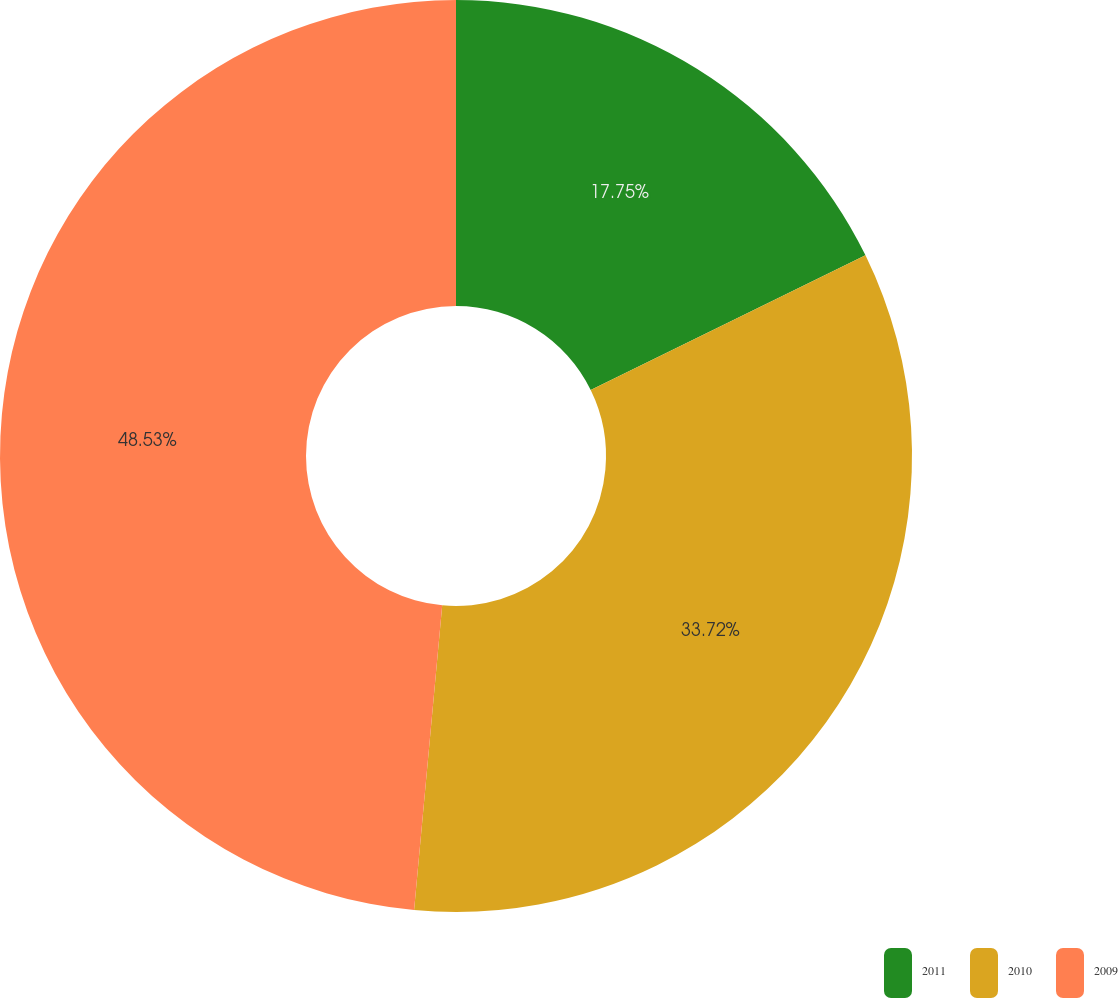Convert chart to OTSL. <chart><loc_0><loc_0><loc_500><loc_500><pie_chart><fcel>2011<fcel>2010<fcel>2009<nl><fcel>17.75%<fcel>33.72%<fcel>48.54%<nl></chart> 